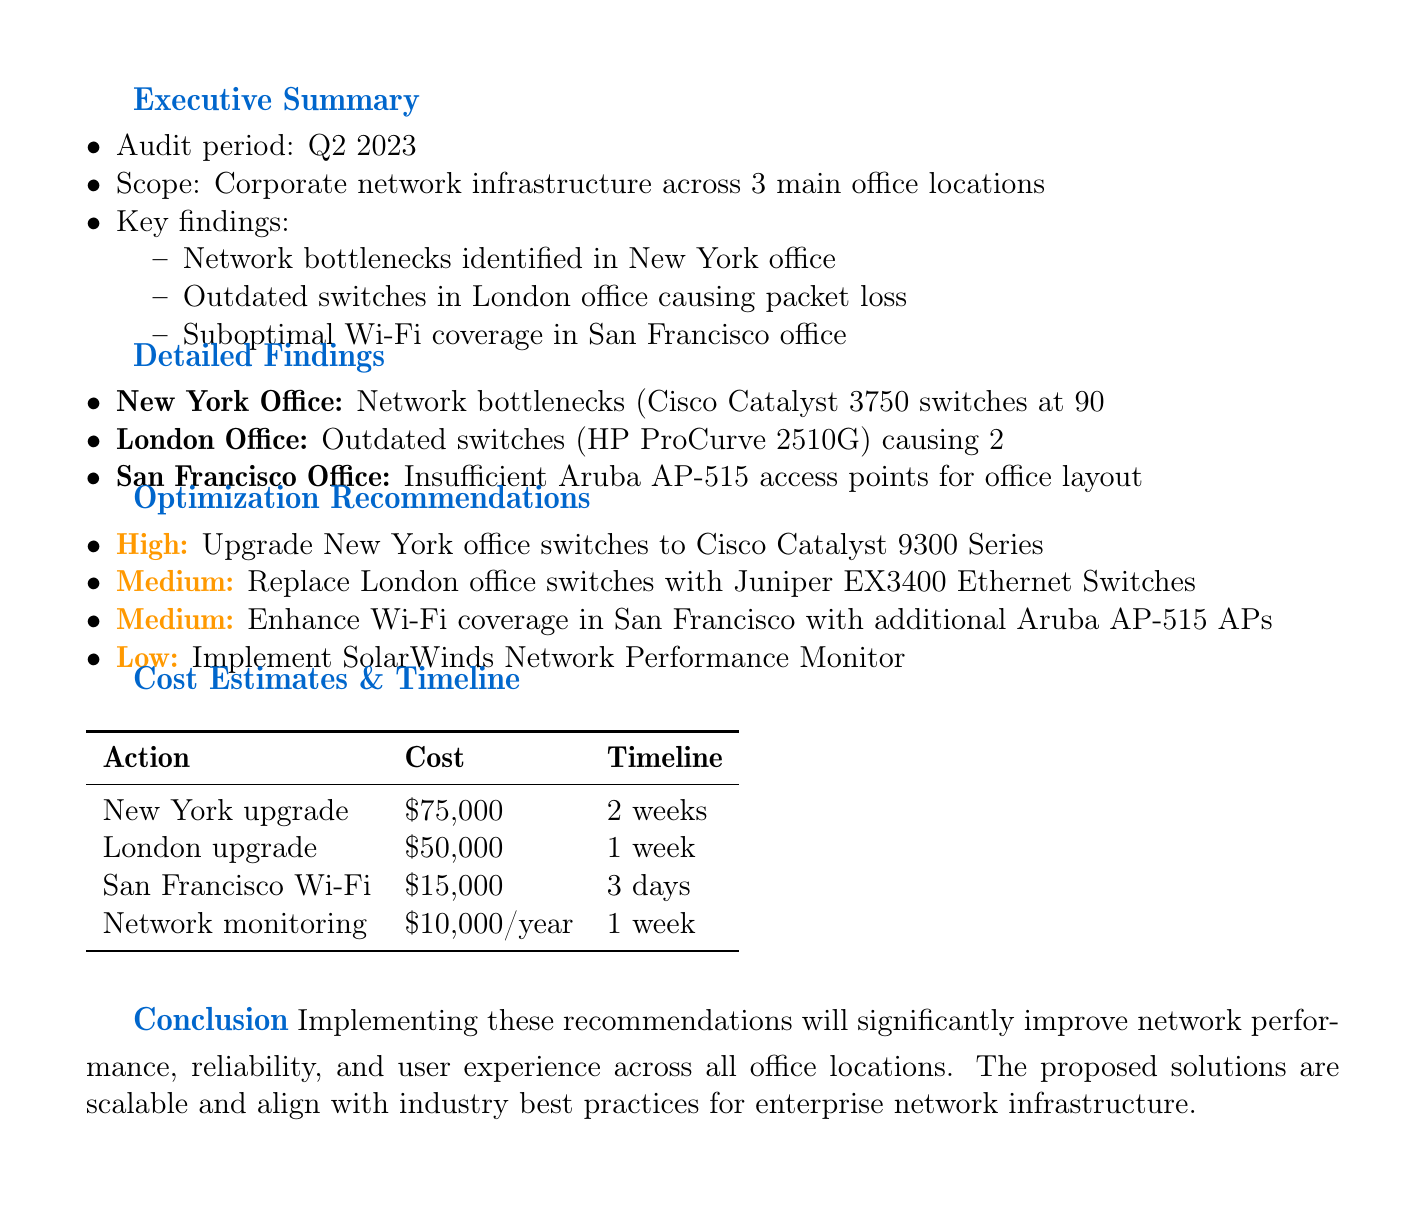What is the audit period? The audit period refers to the timeframe during which the network performance audit was conducted, which is specified in the executive summary.
Answer: Q2 2023 What location has outdated switches? This question seeks to identify the specific office location mentioned in the detailed findings that dealt with outdated switches.
Answer: London Office What is the impact of network bottlenecks in New York? This question looks for the consequence of the identified issue in the New York office as detailed in the findings.
Answer: Slow application response times and reduced productivity What is the expected outcome of upgrading the New York office switches? This question focuses on the benefits expected from the proposed action of upgrading switches in New York office.
Answer: Increased throughput and reduced network congestion How much will the London office upgrade cost? This question asks for the budgetary requirement for the planned upgrade of the London office's network infrastructure.
Answer: $50,000 What is the implementation timeline for enhancing Wi-Fi coverage in San Francisco? This question inquires about how long it will take to enhance the Wi-Fi coverage in the specified office location according to the timeline provided.
Answer: 3 days Which network monitoring solution is recommended? This question asks for the specific name of the network monitoring tool suggested in the recommendations section of the memo.
Answer: SolarWinds Network Performance Monitor What is the priority level for enhancing Wi-Fi coverage in San Francisco? This question seeks to determine the priority classification given to the recommendation concerning Wi-Fi enhancements in San Francisco office.
Answer: Medium 